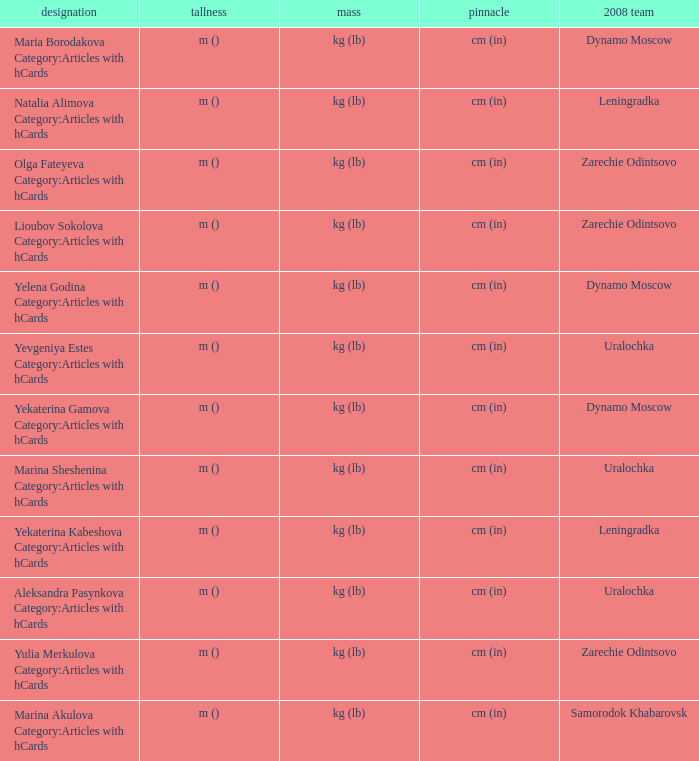What is the name when the 2008 club is uralochka? Yevgeniya Estes Category:Articles with hCards, Marina Sheshenina Category:Articles with hCards, Aleksandra Pasynkova Category:Articles with hCards. 